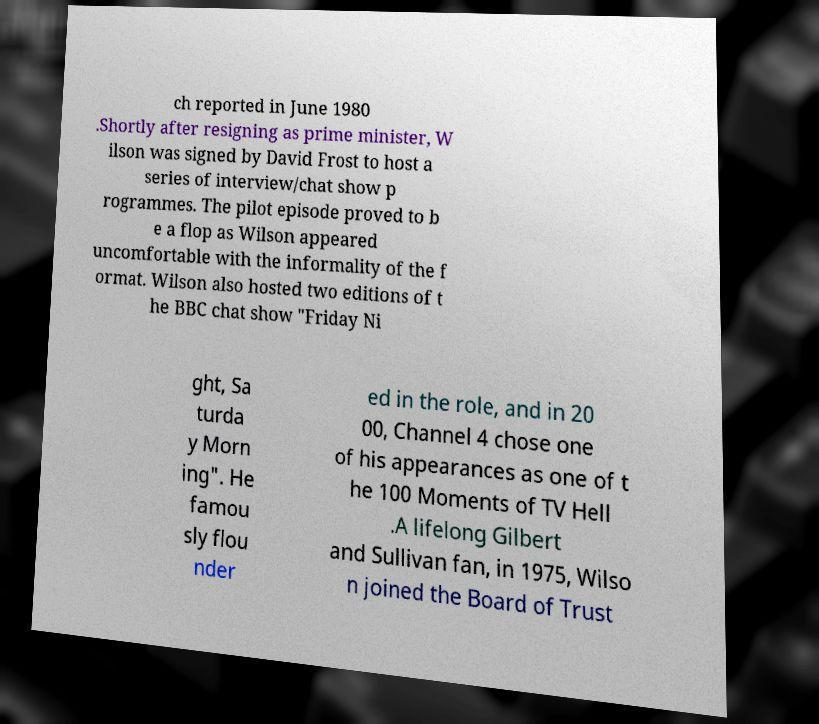Can you read and provide the text displayed in the image?This photo seems to have some interesting text. Can you extract and type it out for me? ch reported in June 1980 .Shortly after resigning as prime minister, W ilson was signed by David Frost to host a series of interview/chat show p rogrammes. The pilot episode proved to b e a flop as Wilson appeared uncomfortable with the informality of the f ormat. Wilson also hosted two editions of t he BBC chat show "Friday Ni ght, Sa turda y Morn ing". He famou sly flou nder ed in the role, and in 20 00, Channel 4 chose one of his appearances as one of t he 100 Moments of TV Hell .A lifelong Gilbert and Sullivan fan, in 1975, Wilso n joined the Board of Trust 